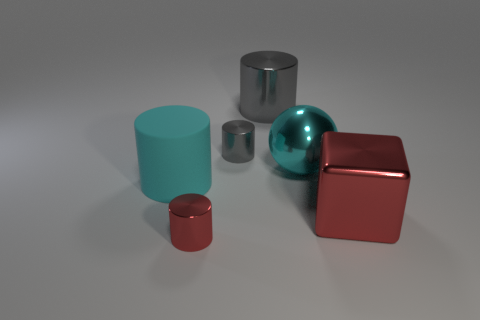Are there any large blue metallic blocks?
Your response must be concise. No. There is a metal cylinder that is left of the big gray cylinder and behind the small red shiny cylinder; what size is it?
Keep it short and to the point. Small. Are there more cyan rubber objects behind the metallic sphere than shiny blocks that are left of the large shiny cylinder?
Ensure brevity in your answer.  No. There is a thing that is the same color as the rubber cylinder; what is its size?
Your answer should be very brief. Large. The shiny cube is what color?
Your answer should be very brief. Red. What color is the object that is right of the small gray thing and in front of the cyan sphere?
Provide a succinct answer. Red. The tiny thing that is in front of the tiny cylinder behind the tiny shiny thing in front of the large cyan metallic sphere is what color?
Offer a very short reply. Red. The metal sphere that is the same size as the metallic block is what color?
Ensure brevity in your answer.  Cyan. What shape is the red thing to the right of the cylinder in front of the large cyan thing to the left of the cyan ball?
Offer a very short reply. Cube. There is a object that is the same color as the metallic cube; what shape is it?
Provide a short and direct response. Cylinder. 